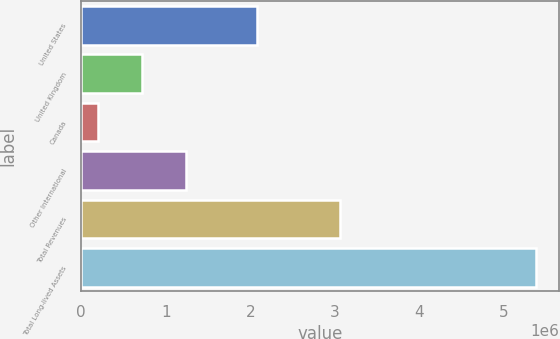<chart> <loc_0><loc_0><loc_500><loc_500><bar_chart><fcel>United States<fcel>United Kingdom<fcel>Canada<fcel>Other International<fcel>Total Revenues<fcel>Total Long-lived Assets<nl><fcel>2.07488e+06<fcel>715374<fcel>197031<fcel>1.23372e+06<fcel>3.05513e+06<fcel>5.38046e+06<nl></chart> 